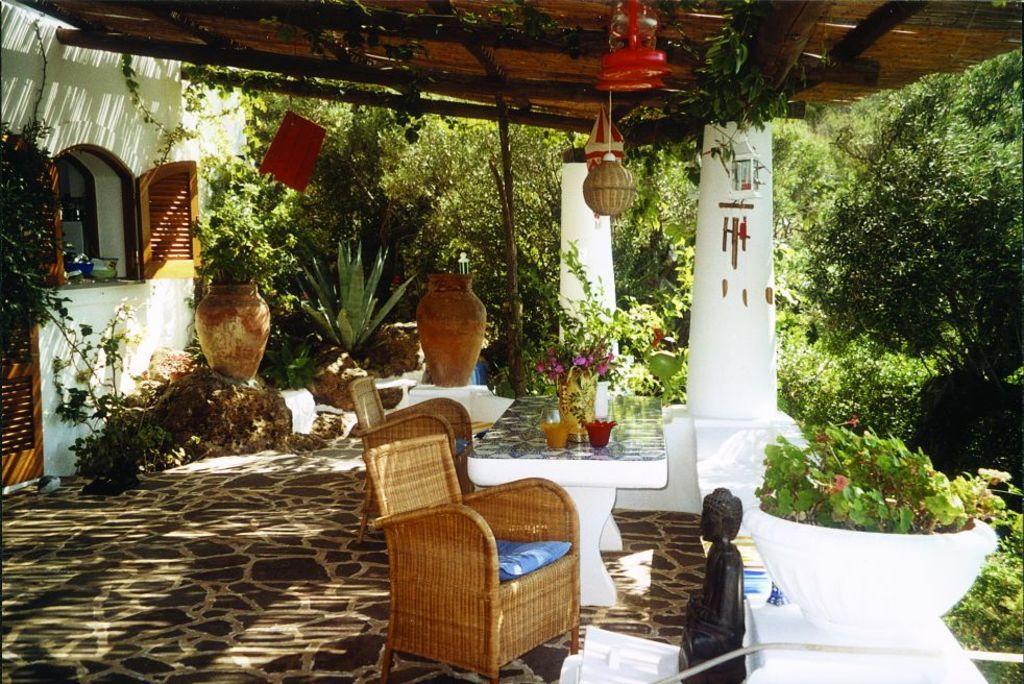Describe this image in one or two sentences. In this picture there is a chair, Buddha statue, a pot, two pillars, a window. In the background we can see flower pots, trees and a table. On the table there is a flower vase and two bowls. 